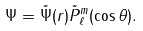<formula> <loc_0><loc_0><loc_500><loc_500>\Psi = \tilde { \Psi } ( r ) \tilde { P } ^ { m } _ { \ell } ( \cos \theta ) .</formula> 